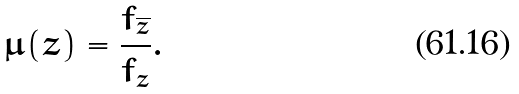<formula> <loc_0><loc_0><loc_500><loc_500>\mu ( z ) = \frac { f _ { \overline { z } } } { f _ { z } } .</formula> 